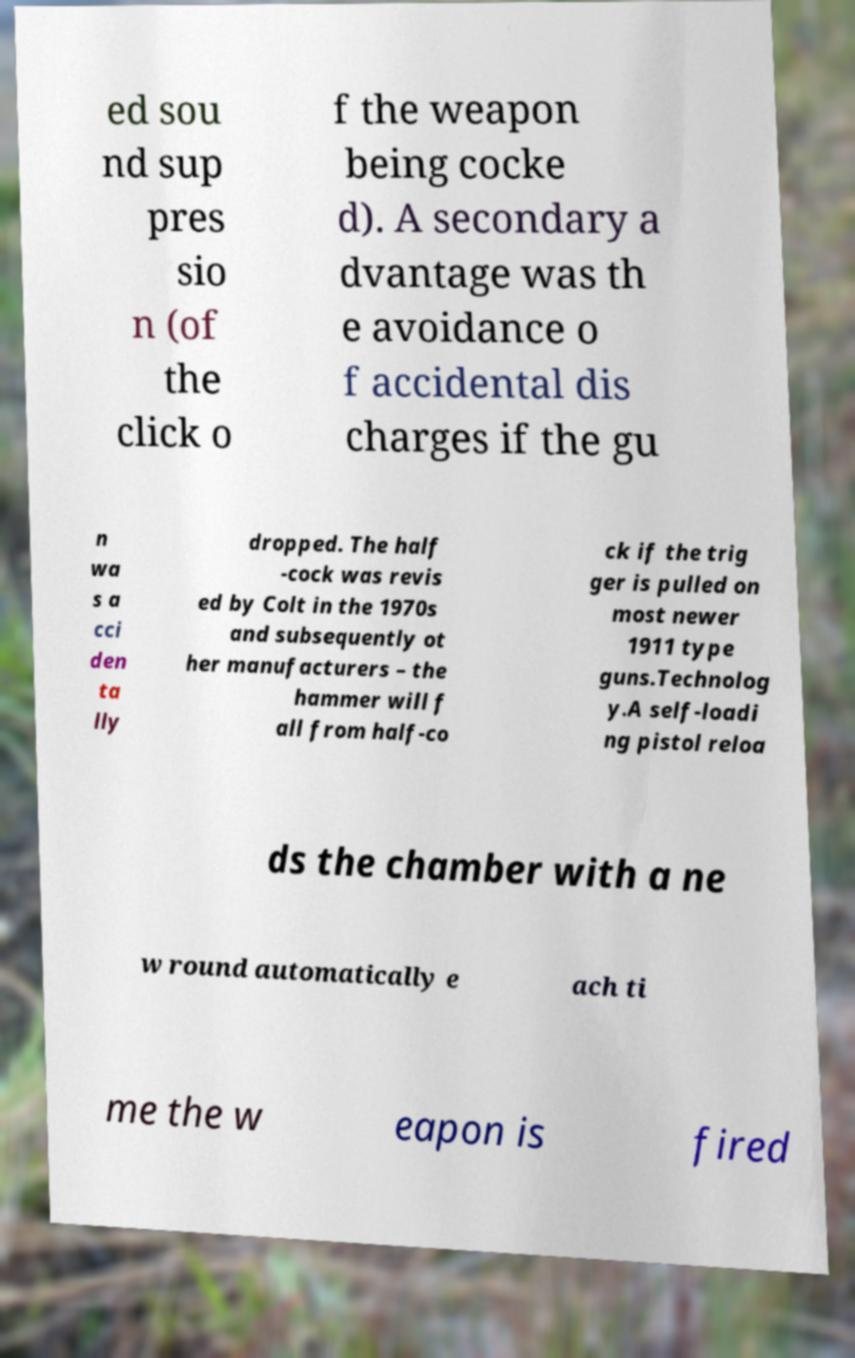Please read and relay the text visible in this image. What does it say? ed sou nd sup pres sio n (of the click o f the weapon being cocke d). A secondary a dvantage was th e avoidance o f accidental dis charges if the gu n wa s a cci den ta lly dropped. The half -cock was revis ed by Colt in the 1970s and subsequently ot her manufacturers – the hammer will f all from half-co ck if the trig ger is pulled on most newer 1911 type guns.Technolog y.A self-loadi ng pistol reloa ds the chamber with a ne w round automatically e ach ti me the w eapon is fired 